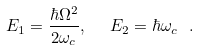Convert formula to latex. <formula><loc_0><loc_0><loc_500><loc_500>E _ { 1 } = \frac { \hbar { \Omega } ^ { 2 } } { 2 \omega _ { c } } , \ \ E _ { 2 } = \hbar { \omega } _ { c } \ .</formula> 